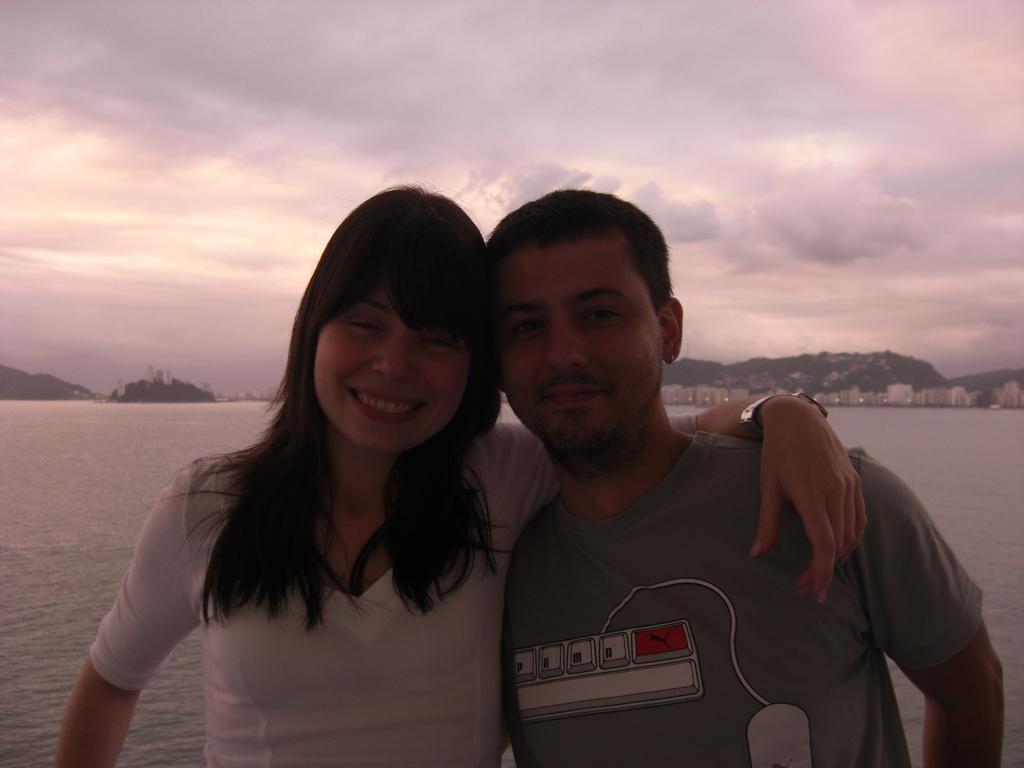How would you summarize this image in a sentence or two? In this image, we can see a woman and man are watching and smiling. Woman is keeping her hand on the man's shoulder. Background we can see water, mountains, buildings and cloudy sky. 